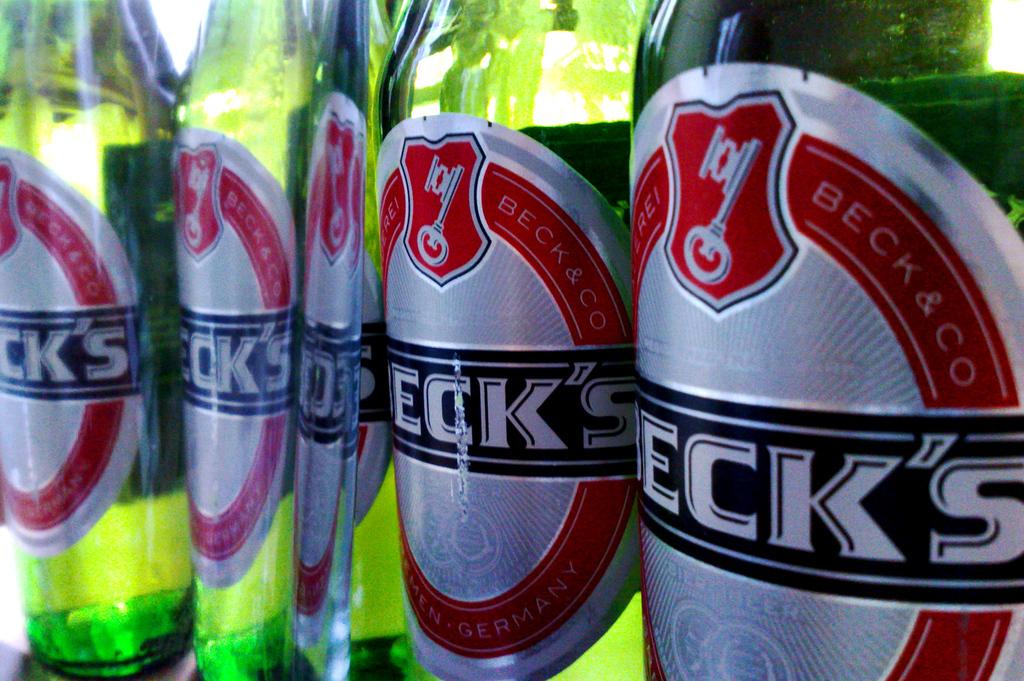What beer brand is shown here?
Your answer should be very brief. Beck's. 